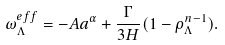<formula> <loc_0><loc_0><loc_500><loc_500>\omega _ { \Lambda } ^ { e f f } = - A a ^ { \alpha } + \frac { \Gamma } { 3 H } ( 1 - \rho _ { \Lambda } ^ { n - 1 } ) .</formula> 